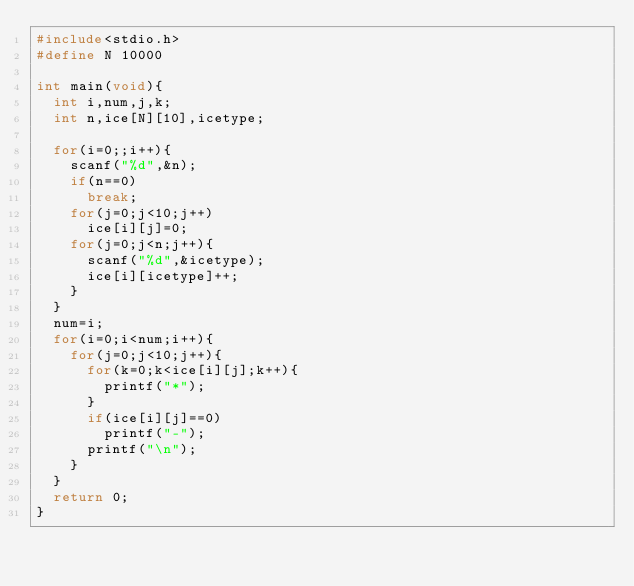Convert code to text. <code><loc_0><loc_0><loc_500><loc_500><_C_>#include<stdio.h>
#define N 10000

int main(void){
  int i,num,j,k;
  int n,ice[N][10],icetype;

  for(i=0;;i++){
    scanf("%d",&n);
    if(n==0)
      break;
    for(j=0;j<10;j++)
      ice[i][j]=0;
    for(j=0;j<n;j++){
      scanf("%d",&icetype);
      ice[i][icetype]++;
    }
  }
  num=i;
  for(i=0;i<num;i++){
    for(j=0;j<10;j++){
      for(k=0;k<ice[i][j];k++){
        printf("*");
      }
      if(ice[i][j]==0)
        printf("-");
      printf("\n");
    }
  }
  return 0;
}</code> 